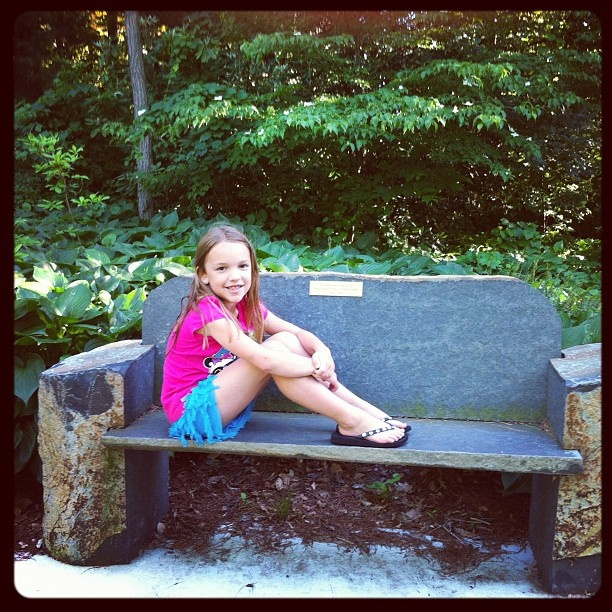Describe the objects in this image and their specific colors. I can see bench in black, gray, and darkgray tones and people in black, white, lightpink, brown, and magenta tones in this image. 